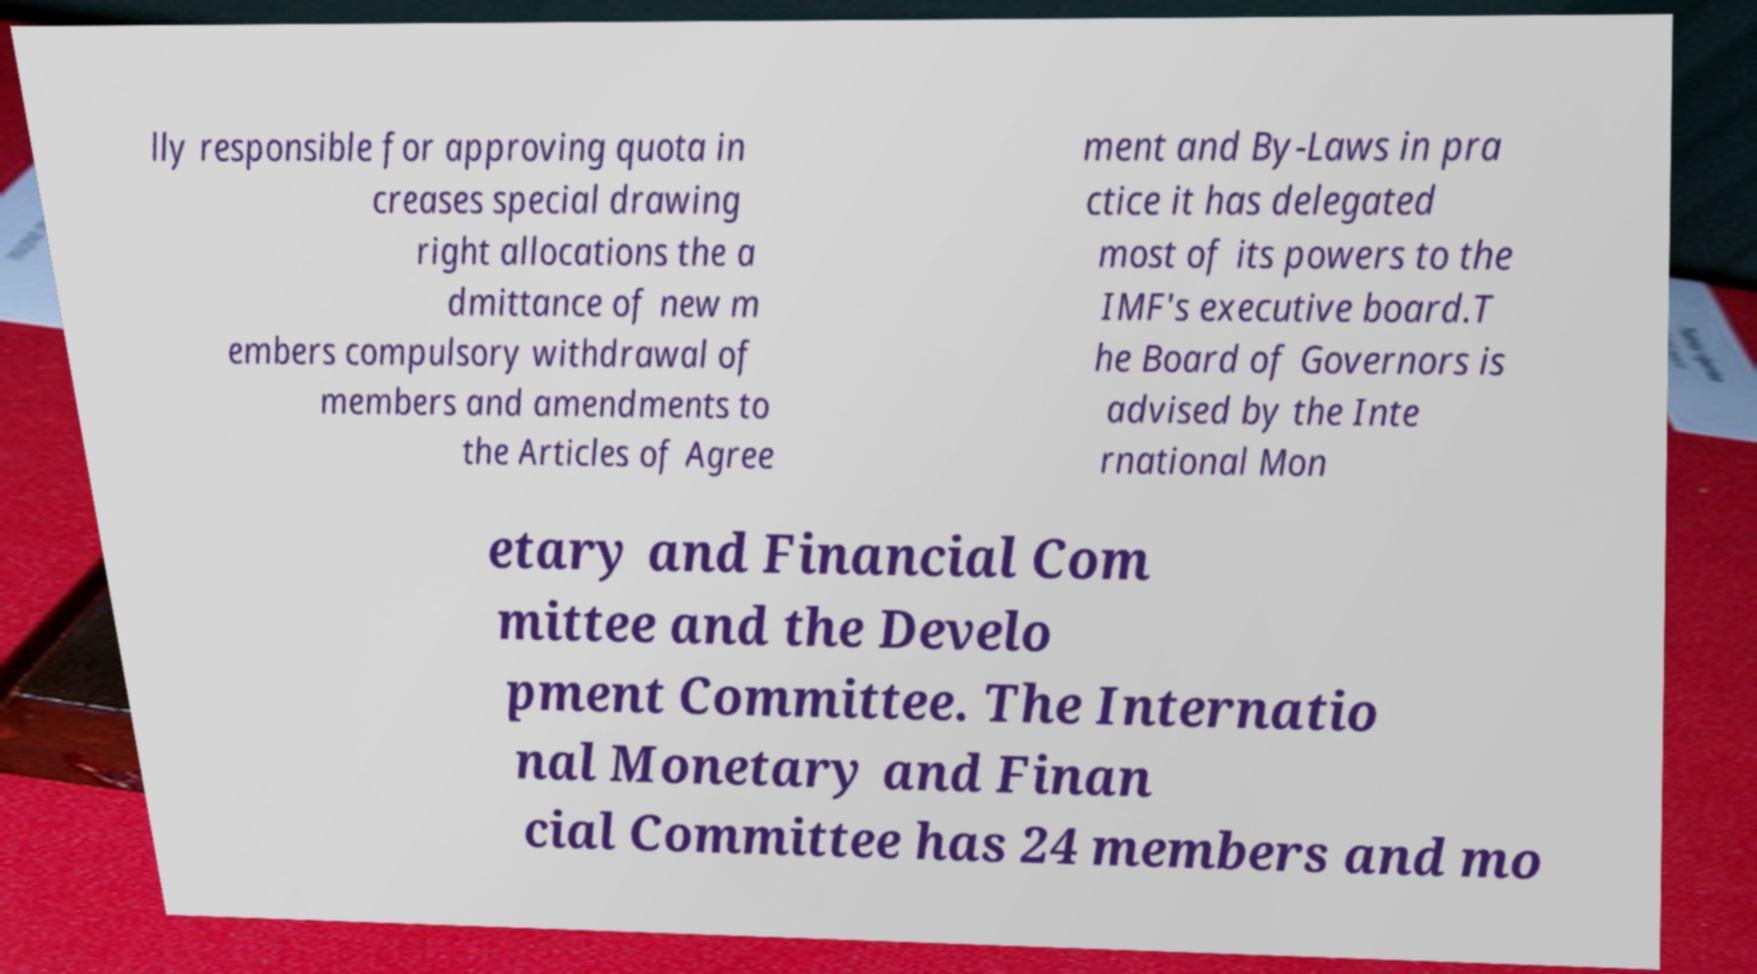Please identify and transcribe the text found in this image. lly responsible for approving quota in creases special drawing right allocations the a dmittance of new m embers compulsory withdrawal of members and amendments to the Articles of Agree ment and By-Laws in pra ctice it has delegated most of its powers to the IMF's executive board.T he Board of Governors is advised by the Inte rnational Mon etary and Financial Com mittee and the Develo pment Committee. The Internatio nal Monetary and Finan cial Committee has 24 members and mo 